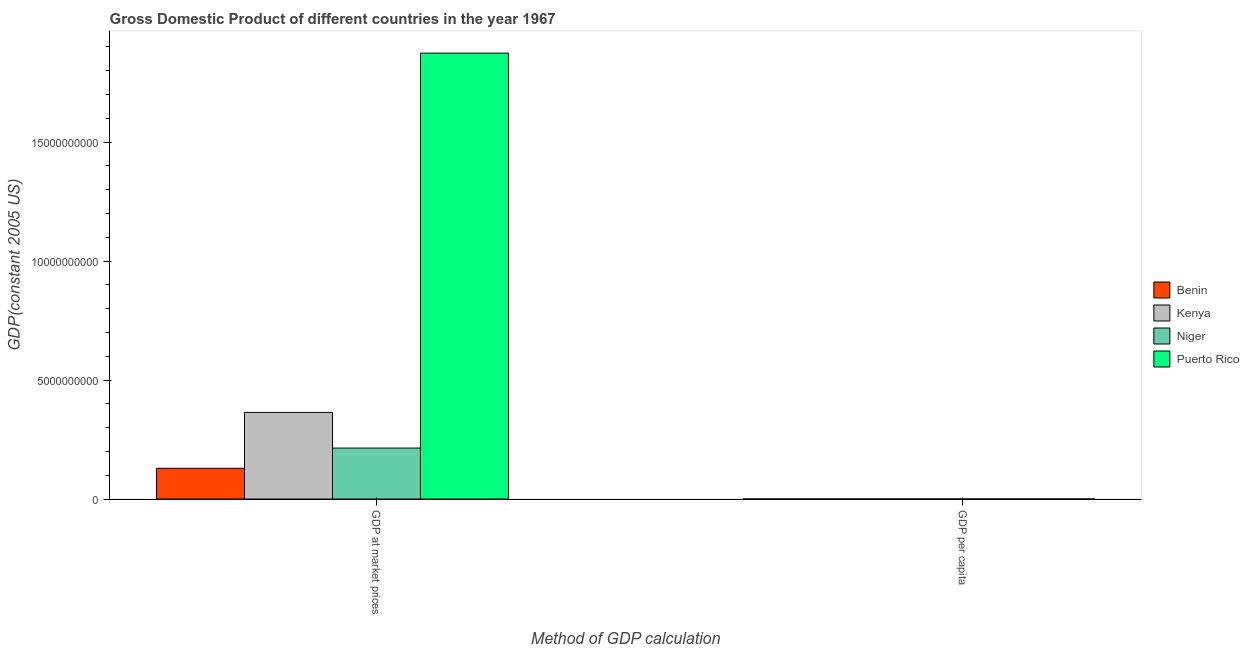How many bars are there on the 2nd tick from the left?
Give a very brief answer. 4. How many bars are there on the 1st tick from the right?
Make the answer very short. 4. What is the label of the 2nd group of bars from the left?
Keep it short and to the point. GDP per capita. What is the gdp per capita in Niger?
Offer a terse response. 516.78. Across all countries, what is the maximum gdp per capita?
Provide a short and direct response. 7082.65. Across all countries, what is the minimum gdp at market prices?
Your response must be concise. 1.29e+09. In which country was the gdp per capita maximum?
Offer a terse response. Puerto Rico. In which country was the gdp at market prices minimum?
Your response must be concise. Benin. What is the total gdp at market prices in the graph?
Offer a terse response. 2.58e+1. What is the difference between the gdp at market prices in Niger and that in Kenya?
Your answer should be very brief. -1.50e+09. What is the difference between the gdp at market prices in Niger and the gdp per capita in Kenya?
Make the answer very short. 2.14e+09. What is the average gdp at market prices per country?
Make the answer very short. 6.45e+09. What is the difference between the gdp at market prices and gdp per capita in Puerto Rico?
Offer a terse response. 1.87e+1. In how many countries, is the gdp per capita greater than 15000000000 US$?
Give a very brief answer. 0. What is the ratio of the gdp at market prices in Kenya to that in Benin?
Your response must be concise. 2.82. In how many countries, is the gdp at market prices greater than the average gdp at market prices taken over all countries?
Ensure brevity in your answer.  1. What does the 1st bar from the left in GDP at market prices represents?
Provide a succinct answer. Benin. What does the 1st bar from the right in GDP at market prices represents?
Make the answer very short. Puerto Rico. Are all the bars in the graph horizontal?
Provide a succinct answer. No. What is the difference between two consecutive major ticks on the Y-axis?
Provide a short and direct response. 5.00e+09. Are the values on the major ticks of Y-axis written in scientific E-notation?
Make the answer very short. No. Where does the legend appear in the graph?
Make the answer very short. Center right. How are the legend labels stacked?
Offer a terse response. Vertical. What is the title of the graph?
Make the answer very short. Gross Domestic Product of different countries in the year 1967. Does "Portugal" appear as one of the legend labels in the graph?
Give a very brief answer. No. What is the label or title of the X-axis?
Offer a very short reply. Method of GDP calculation. What is the label or title of the Y-axis?
Your response must be concise. GDP(constant 2005 US). What is the GDP(constant 2005 US) of Benin in GDP at market prices?
Offer a terse response. 1.29e+09. What is the GDP(constant 2005 US) in Kenya in GDP at market prices?
Your answer should be very brief. 3.64e+09. What is the GDP(constant 2005 US) in Niger in GDP at market prices?
Provide a short and direct response. 2.14e+09. What is the GDP(constant 2005 US) in Puerto Rico in GDP at market prices?
Offer a very short reply. 1.87e+1. What is the GDP(constant 2005 US) in Benin in GDP per capita?
Offer a very short reply. 472.46. What is the GDP(constant 2005 US) in Kenya in GDP per capita?
Your response must be concise. 358.48. What is the GDP(constant 2005 US) of Niger in GDP per capita?
Offer a very short reply. 516.78. What is the GDP(constant 2005 US) in Puerto Rico in GDP per capita?
Your answer should be compact. 7082.65. Across all Method of GDP calculation, what is the maximum GDP(constant 2005 US) in Benin?
Your answer should be compact. 1.29e+09. Across all Method of GDP calculation, what is the maximum GDP(constant 2005 US) in Kenya?
Provide a short and direct response. 3.64e+09. Across all Method of GDP calculation, what is the maximum GDP(constant 2005 US) of Niger?
Offer a terse response. 2.14e+09. Across all Method of GDP calculation, what is the maximum GDP(constant 2005 US) in Puerto Rico?
Provide a short and direct response. 1.87e+1. Across all Method of GDP calculation, what is the minimum GDP(constant 2005 US) in Benin?
Ensure brevity in your answer.  472.46. Across all Method of GDP calculation, what is the minimum GDP(constant 2005 US) of Kenya?
Offer a very short reply. 358.48. Across all Method of GDP calculation, what is the minimum GDP(constant 2005 US) in Niger?
Ensure brevity in your answer.  516.78. Across all Method of GDP calculation, what is the minimum GDP(constant 2005 US) of Puerto Rico?
Make the answer very short. 7082.65. What is the total GDP(constant 2005 US) in Benin in the graph?
Offer a very short reply. 1.29e+09. What is the total GDP(constant 2005 US) of Kenya in the graph?
Ensure brevity in your answer.  3.64e+09. What is the total GDP(constant 2005 US) in Niger in the graph?
Offer a terse response. 2.14e+09. What is the total GDP(constant 2005 US) of Puerto Rico in the graph?
Offer a terse response. 1.87e+1. What is the difference between the GDP(constant 2005 US) in Benin in GDP at market prices and that in GDP per capita?
Make the answer very short. 1.29e+09. What is the difference between the GDP(constant 2005 US) of Kenya in GDP at market prices and that in GDP per capita?
Provide a short and direct response. 3.64e+09. What is the difference between the GDP(constant 2005 US) in Niger in GDP at market prices and that in GDP per capita?
Ensure brevity in your answer.  2.14e+09. What is the difference between the GDP(constant 2005 US) of Puerto Rico in GDP at market prices and that in GDP per capita?
Offer a very short reply. 1.87e+1. What is the difference between the GDP(constant 2005 US) in Benin in GDP at market prices and the GDP(constant 2005 US) in Kenya in GDP per capita?
Your response must be concise. 1.29e+09. What is the difference between the GDP(constant 2005 US) in Benin in GDP at market prices and the GDP(constant 2005 US) in Niger in GDP per capita?
Provide a succinct answer. 1.29e+09. What is the difference between the GDP(constant 2005 US) of Benin in GDP at market prices and the GDP(constant 2005 US) of Puerto Rico in GDP per capita?
Make the answer very short. 1.29e+09. What is the difference between the GDP(constant 2005 US) of Kenya in GDP at market prices and the GDP(constant 2005 US) of Niger in GDP per capita?
Ensure brevity in your answer.  3.64e+09. What is the difference between the GDP(constant 2005 US) in Kenya in GDP at market prices and the GDP(constant 2005 US) in Puerto Rico in GDP per capita?
Your response must be concise. 3.64e+09. What is the difference between the GDP(constant 2005 US) in Niger in GDP at market prices and the GDP(constant 2005 US) in Puerto Rico in GDP per capita?
Offer a terse response. 2.14e+09. What is the average GDP(constant 2005 US) in Benin per Method of GDP calculation?
Keep it short and to the point. 6.46e+08. What is the average GDP(constant 2005 US) of Kenya per Method of GDP calculation?
Your answer should be very brief. 1.82e+09. What is the average GDP(constant 2005 US) in Niger per Method of GDP calculation?
Your answer should be compact. 1.07e+09. What is the average GDP(constant 2005 US) of Puerto Rico per Method of GDP calculation?
Your response must be concise. 9.37e+09. What is the difference between the GDP(constant 2005 US) of Benin and GDP(constant 2005 US) of Kenya in GDP at market prices?
Give a very brief answer. -2.35e+09. What is the difference between the GDP(constant 2005 US) of Benin and GDP(constant 2005 US) of Niger in GDP at market prices?
Provide a succinct answer. -8.50e+08. What is the difference between the GDP(constant 2005 US) of Benin and GDP(constant 2005 US) of Puerto Rico in GDP at market prices?
Give a very brief answer. -1.74e+1. What is the difference between the GDP(constant 2005 US) of Kenya and GDP(constant 2005 US) of Niger in GDP at market prices?
Keep it short and to the point. 1.50e+09. What is the difference between the GDP(constant 2005 US) of Kenya and GDP(constant 2005 US) of Puerto Rico in GDP at market prices?
Give a very brief answer. -1.51e+1. What is the difference between the GDP(constant 2005 US) in Niger and GDP(constant 2005 US) in Puerto Rico in GDP at market prices?
Ensure brevity in your answer.  -1.66e+1. What is the difference between the GDP(constant 2005 US) of Benin and GDP(constant 2005 US) of Kenya in GDP per capita?
Your answer should be compact. 113.98. What is the difference between the GDP(constant 2005 US) of Benin and GDP(constant 2005 US) of Niger in GDP per capita?
Your answer should be very brief. -44.32. What is the difference between the GDP(constant 2005 US) of Benin and GDP(constant 2005 US) of Puerto Rico in GDP per capita?
Make the answer very short. -6610.19. What is the difference between the GDP(constant 2005 US) in Kenya and GDP(constant 2005 US) in Niger in GDP per capita?
Your response must be concise. -158.3. What is the difference between the GDP(constant 2005 US) of Kenya and GDP(constant 2005 US) of Puerto Rico in GDP per capita?
Ensure brevity in your answer.  -6724.18. What is the difference between the GDP(constant 2005 US) of Niger and GDP(constant 2005 US) of Puerto Rico in GDP per capita?
Provide a short and direct response. -6565.88. What is the ratio of the GDP(constant 2005 US) in Benin in GDP at market prices to that in GDP per capita?
Provide a short and direct response. 2.73e+06. What is the ratio of the GDP(constant 2005 US) in Kenya in GDP at market prices to that in GDP per capita?
Your answer should be very brief. 1.02e+07. What is the ratio of the GDP(constant 2005 US) of Niger in GDP at market prices to that in GDP per capita?
Offer a terse response. 4.14e+06. What is the ratio of the GDP(constant 2005 US) of Puerto Rico in GDP at market prices to that in GDP per capita?
Your answer should be very brief. 2.65e+06. What is the difference between the highest and the second highest GDP(constant 2005 US) of Benin?
Keep it short and to the point. 1.29e+09. What is the difference between the highest and the second highest GDP(constant 2005 US) of Kenya?
Give a very brief answer. 3.64e+09. What is the difference between the highest and the second highest GDP(constant 2005 US) of Niger?
Keep it short and to the point. 2.14e+09. What is the difference between the highest and the second highest GDP(constant 2005 US) in Puerto Rico?
Offer a terse response. 1.87e+1. What is the difference between the highest and the lowest GDP(constant 2005 US) of Benin?
Give a very brief answer. 1.29e+09. What is the difference between the highest and the lowest GDP(constant 2005 US) in Kenya?
Offer a very short reply. 3.64e+09. What is the difference between the highest and the lowest GDP(constant 2005 US) of Niger?
Make the answer very short. 2.14e+09. What is the difference between the highest and the lowest GDP(constant 2005 US) of Puerto Rico?
Offer a terse response. 1.87e+1. 